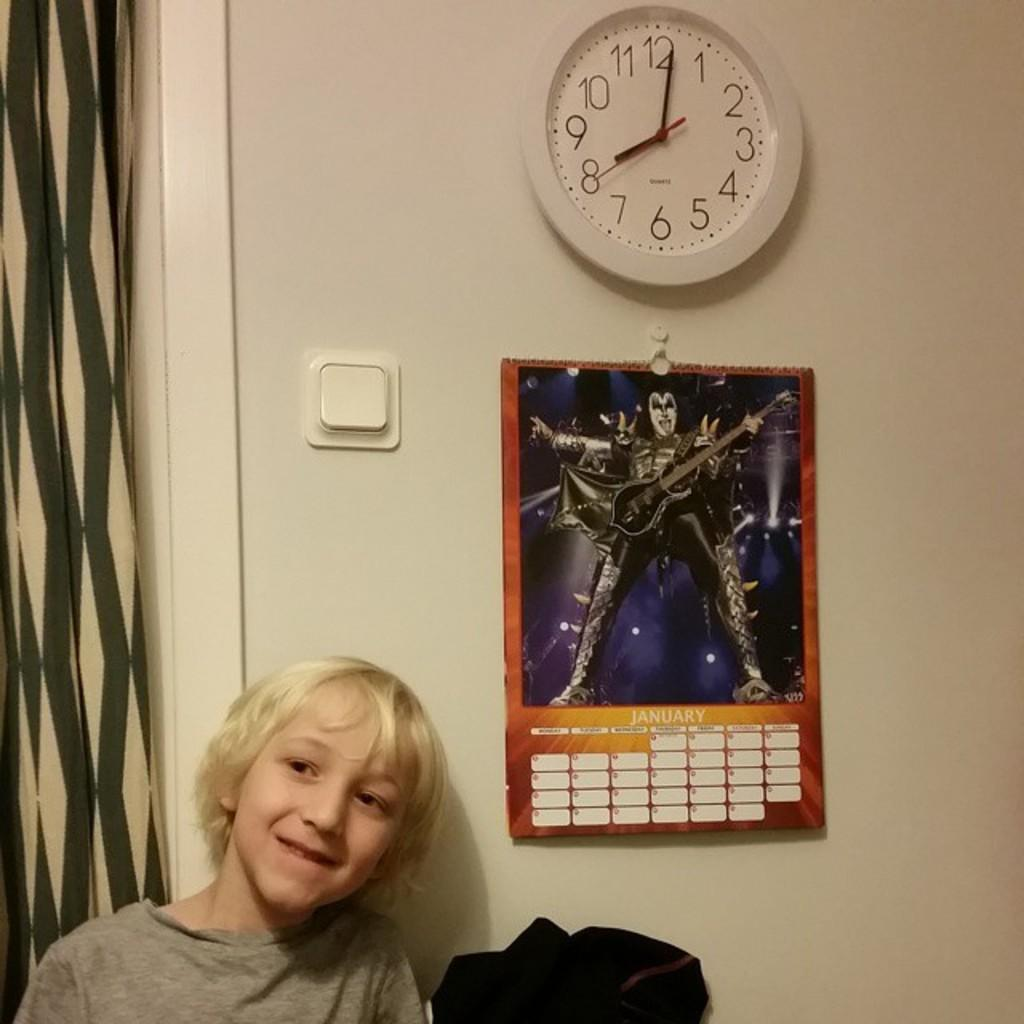<image>
Describe the image concisely. A child is standing by a wall that holds a KISS poster and a clock. 